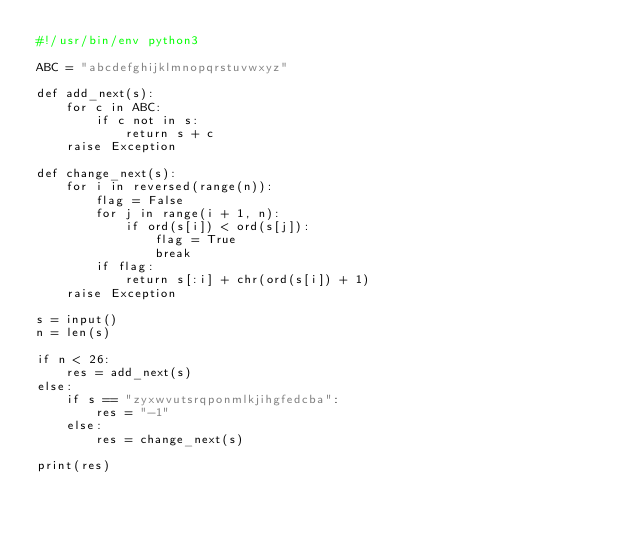<code> <loc_0><loc_0><loc_500><loc_500><_Python_>#!/usr/bin/env python3

ABC = "abcdefghijklmnopqrstuvwxyz"

def add_next(s):    
    for c in ABC:
        if c not in s:
            return s + c
    raise Exception

def change_next(s):
    for i in reversed(range(n)):
        flag = False
        for j in range(i + 1, n):
            if ord(s[i]) < ord(s[j]):
                flag = True
                break
        if flag:
            return s[:i] + chr(ord(s[i]) + 1)
    raise Exception

s = input()
n = len(s)

if n < 26:
    res = add_next(s)
else:
    if s == "zyxwvutsrqponmlkjihgfedcba":
        res = "-1"
    else:
        res = change_next(s)

print(res)
</code> 